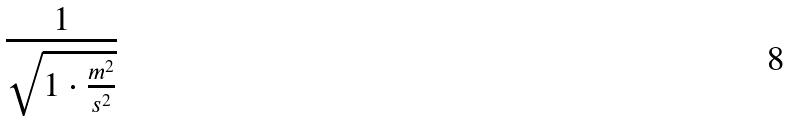<formula> <loc_0><loc_0><loc_500><loc_500>\frac { 1 } { \sqrt { 1 \cdot \frac { m ^ { 2 } } { s ^ { 2 } } } }</formula> 